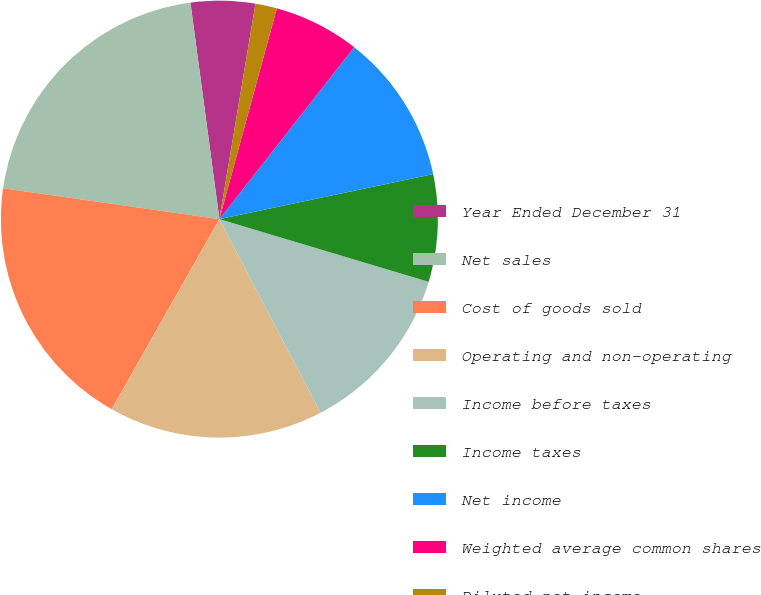Convert chart. <chart><loc_0><loc_0><loc_500><loc_500><pie_chart><fcel>Year Ended December 31<fcel>Net sales<fcel>Cost of goods sold<fcel>Operating and non-operating<fcel>Income before taxes<fcel>Income taxes<fcel>Net income<fcel>Weighted average common shares<fcel>Diluted net income<fcel>Dividends declared<nl><fcel>4.76%<fcel>20.63%<fcel>19.05%<fcel>15.87%<fcel>12.7%<fcel>7.94%<fcel>11.11%<fcel>6.35%<fcel>1.59%<fcel>0.0%<nl></chart> 